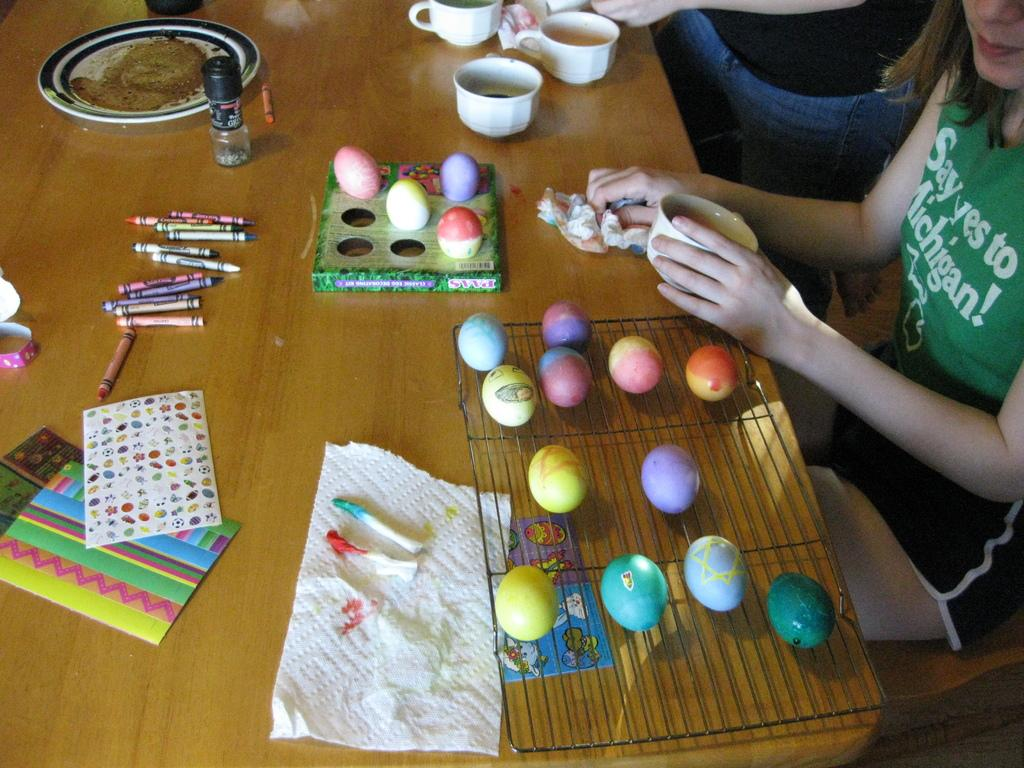What is located at the bottom side of the image? There is a table at the bottom side of the image. What items can be seen on the table? There are cups, crayons, colorful eggs, and stickers on the table. What is present on the right side of the image? There are people on the right side of the image. What type of substance is being used by the people on the right side of the image? There is no specific substance mentioned or visible in the image; it only shows people on the right side. 